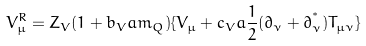<formula> <loc_0><loc_0><loc_500><loc_500>V ^ { R } _ { \mu } = Z _ { V } ( 1 + b _ { V } a m _ { Q } ) \{ V _ { \mu } + c _ { V } a \frac { 1 } { 2 } ( { \partial } _ { \nu } + { \partial } _ { \nu } ^ { ^ { * } } ) T _ { \mu \nu } \}</formula> 